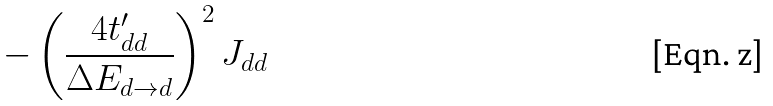<formula> <loc_0><loc_0><loc_500><loc_500>- \left ( \frac { 4 t _ { d d } ^ { \prime } } { \Delta E _ { d \rightarrow d } } \right ) ^ { 2 } J _ { d d }</formula> 